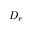Convert formula to latex. <formula><loc_0><loc_0><loc_500><loc_500>D _ { r }</formula> 